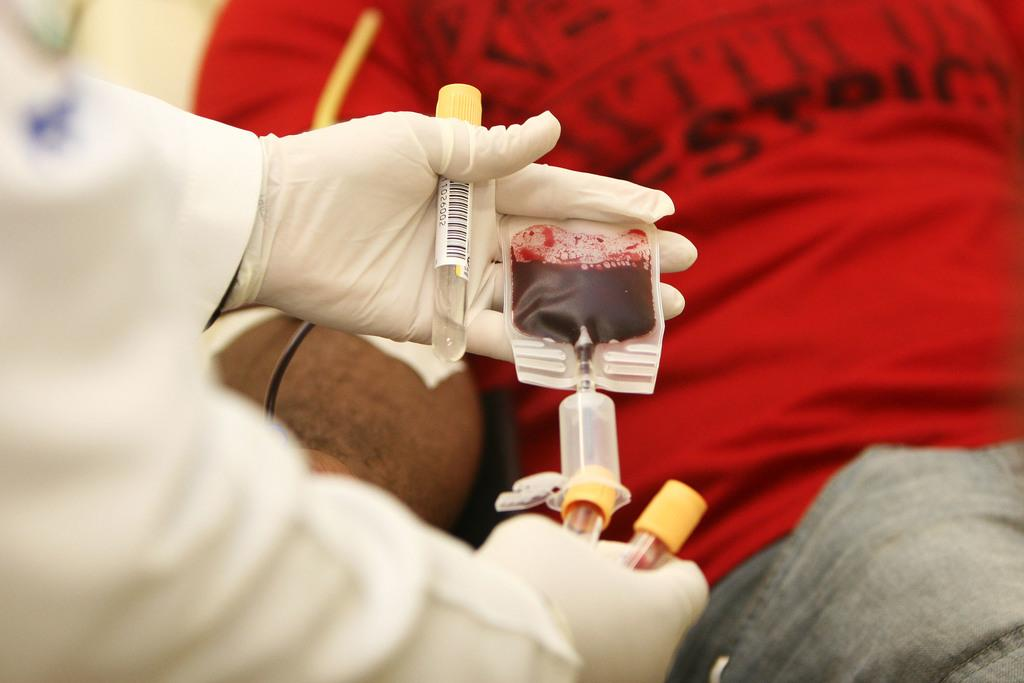What is the main object in the image? There is a blood packet in the image. What is the person holding in their hand? There are small tubes in the person's hand. What is happening between the two people in the image? Blood is being taken from one person by another person. What type of wool is being used to collect the blood in the image? There is no wool present in the image; blood is being collected using small tubes. 